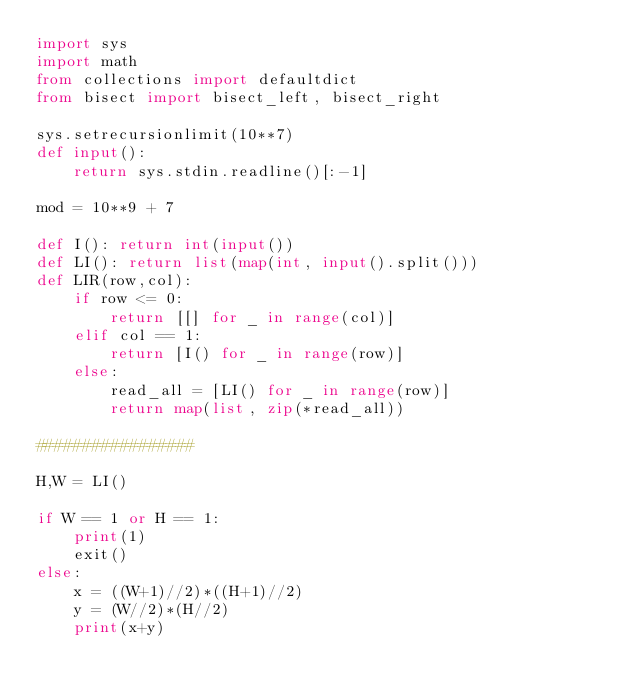Convert code to text. <code><loc_0><loc_0><loc_500><loc_500><_Python_>import sys
import math
from collections import defaultdict
from bisect import bisect_left, bisect_right

sys.setrecursionlimit(10**7)
def input():
    return sys.stdin.readline()[:-1]

mod = 10**9 + 7

def I(): return int(input())
def LI(): return list(map(int, input().split()))
def LIR(row,col):
    if row <= 0:
        return [[] for _ in range(col)]
    elif col == 1:
        return [I() for _ in range(row)]
    else:
        read_all = [LI() for _ in range(row)]
        return map(list, zip(*read_all))

#################

H,W = LI()

if W == 1 or H == 1:
    print(1)
    exit()
else:
    x = ((W+1)//2)*((H+1)//2)
    y = (W//2)*(H//2)
    print(x+y)</code> 